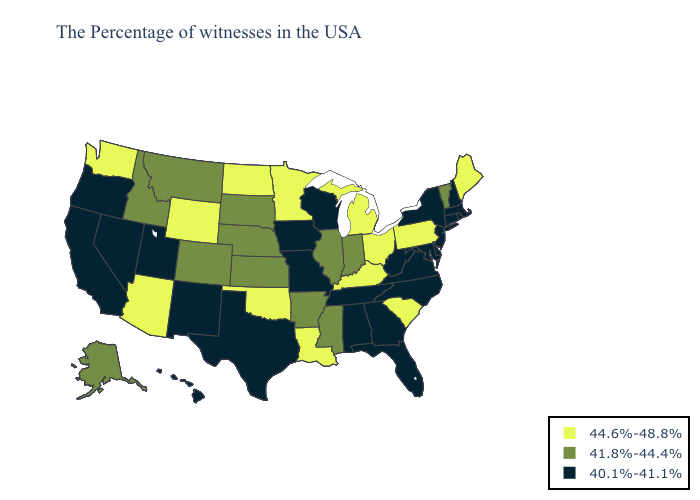What is the value of Iowa?
Concise answer only. 40.1%-41.1%. Among the states that border Mississippi , which have the lowest value?
Concise answer only. Alabama, Tennessee. Among the states that border Michigan , does Indiana have the highest value?
Quick response, please. No. Does Rhode Island have the lowest value in the Northeast?
Give a very brief answer. Yes. Does the first symbol in the legend represent the smallest category?
Quick response, please. No. Which states hav the highest value in the South?
Write a very short answer. South Carolina, Kentucky, Louisiana, Oklahoma. What is the value of Maine?
Quick response, please. 44.6%-48.8%. Which states have the highest value in the USA?
Keep it brief. Maine, Pennsylvania, South Carolina, Ohio, Michigan, Kentucky, Louisiana, Minnesota, Oklahoma, North Dakota, Wyoming, Arizona, Washington. Name the states that have a value in the range 40.1%-41.1%?
Be succinct. Massachusetts, Rhode Island, New Hampshire, Connecticut, New York, New Jersey, Delaware, Maryland, Virginia, North Carolina, West Virginia, Florida, Georgia, Alabama, Tennessee, Wisconsin, Missouri, Iowa, Texas, New Mexico, Utah, Nevada, California, Oregon, Hawaii. What is the value of North Dakota?
Answer briefly. 44.6%-48.8%. Does Arizona have the highest value in the USA?
Write a very short answer. Yes. Does Kansas have the highest value in the USA?
Short answer required. No. Does South Dakota have a higher value than Montana?
Quick response, please. No. Does Maine have the highest value in the USA?
Give a very brief answer. Yes. 